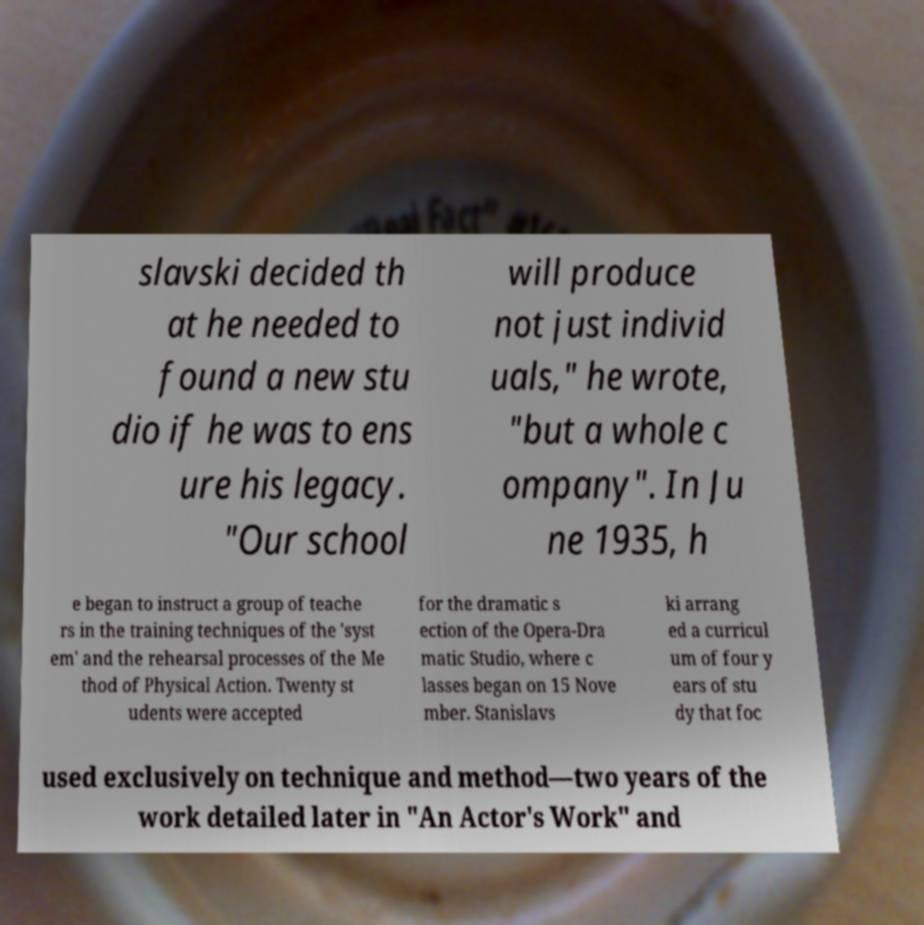Can you read and provide the text displayed in the image?This photo seems to have some interesting text. Can you extract and type it out for me? slavski decided th at he needed to found a new stu dio if he was to ens ure his legacy. "Our school will produce not just individ uals," he wrote, "but a whole c ompany". In Ju ne 1935, h e began to instruct a group of teache rs in the training techniques of the 'syst em' and the rehearsal processes of the Me thod of Physical Action. Twenty st udents were accepted for the dramatic s ection of the Opera-Dra matic Studio, where c lasses began on 15 Nove mber. Stanislavs ki arrang ed a curricul um of four y ears of stu dy that foc used exclusively on technique and method—two years of the work detailed later in "An Actor's Work" and 